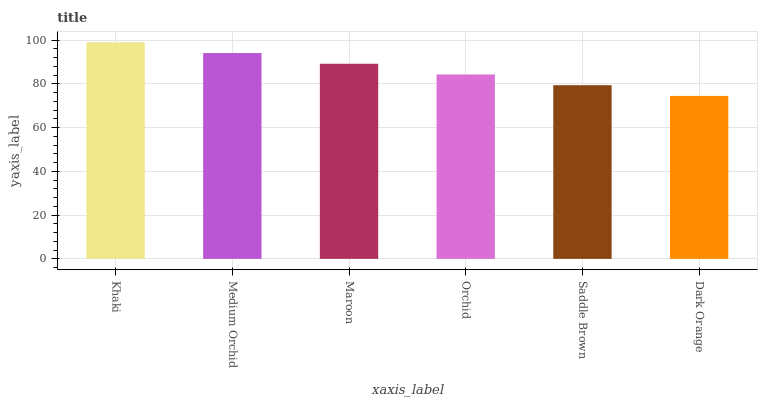Is Dark Orange the minimum?
Answer yes or no. Yes. Is Khaki the maximum?
Answer yes or no. Yes. Is Medium Orchid the minimum?
Answer yes or no. No. Is Medium Orchid the maximum?
Answer yes or no. No. Is Khaki greater than Medium Orchid?
Answer yes or no. Yes. Is Medium Orchid less than Khaki?
Answer yes or no. Yes. Is Medium Orchid greater than Khaki?
Answer yes or no. No. Is Khaki less than Medium Orchid?
Answer yes or no. No. Is Maroon the high median?
Answer yes or no. Yes. Is Orchid the low median?
Answer yes or no. Yes. Is Khaki the high median?
Answer yes or no. No. Is Dark Orange the low median?
Answer yes or no. No. 